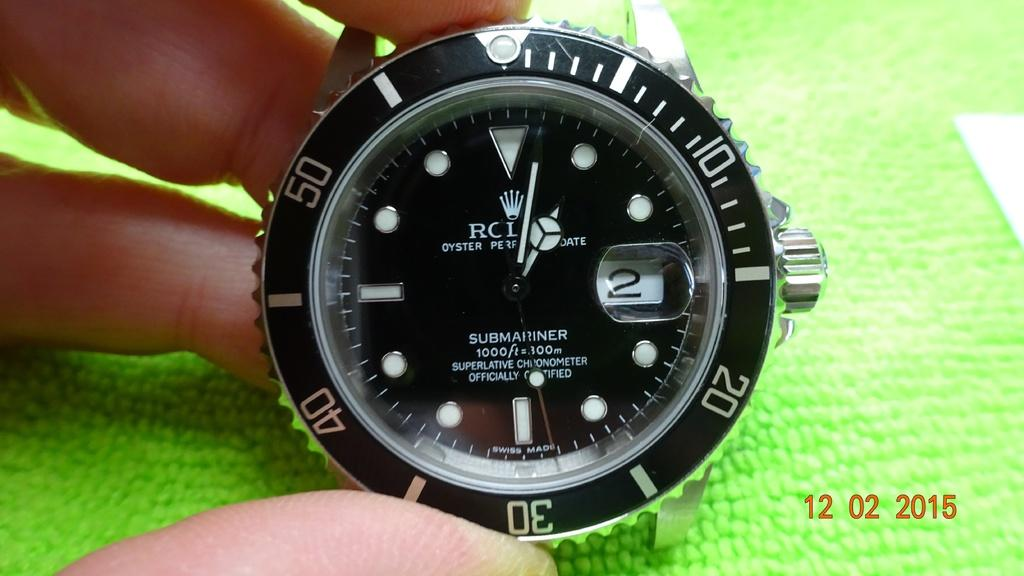<image>
Create a compact narrative representing the image presented. A picture of an RCI Oyster watch was taken in 2015 